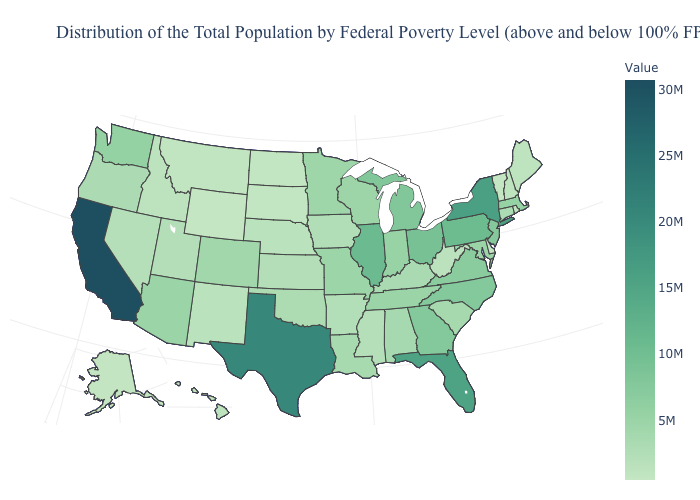Among the states that border Vermont , which have the highest value?
Keep it brief. New York. Does New Mexico have the highest value in the West?
Write a very short answer. No. Among the states that border North Carolina , does South Carolina have the highest value?
Answer briefly. No. Among the states that border New Jersey , which have the highest value?
Short answer required. New York. 